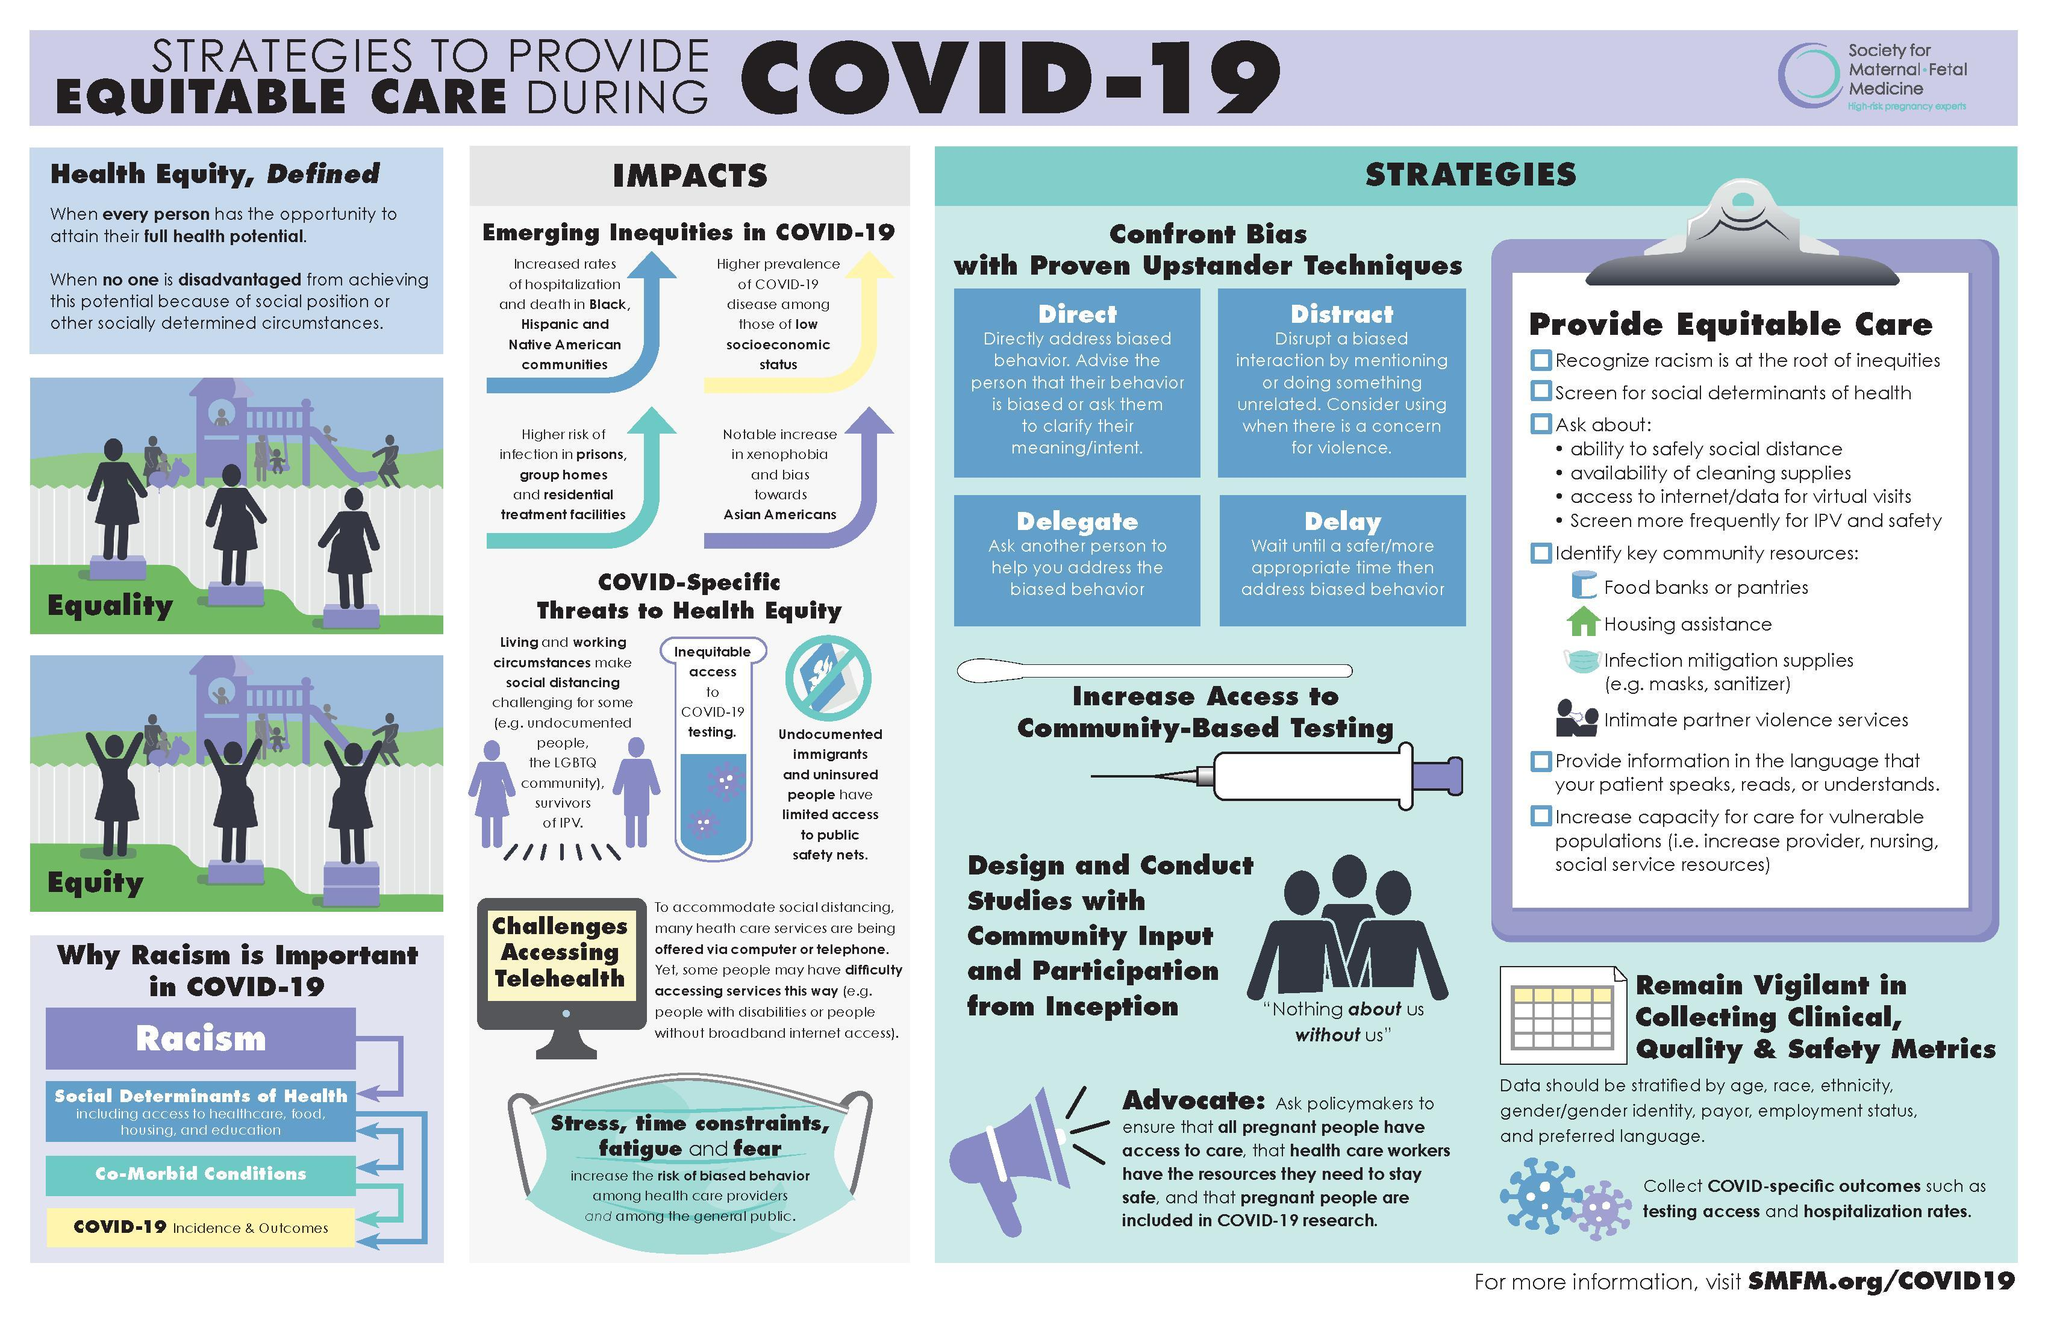How many community resources are in this infographic?
Answer the question with a short phrase. 4 How many factors increase the risk of biased behavior? 4 